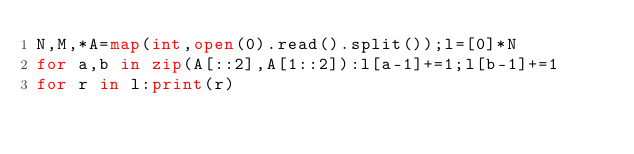<code> <loc_0><loc_0><loc_500><loc_500><_Python_>N,M,*A=map(int,open(0).read().split());l=[0]*N
for a,b in zip(A[::2],A[1::2]):l[a-1]+=1;l[b-1]+=1
for r in l:print(r)</code> 